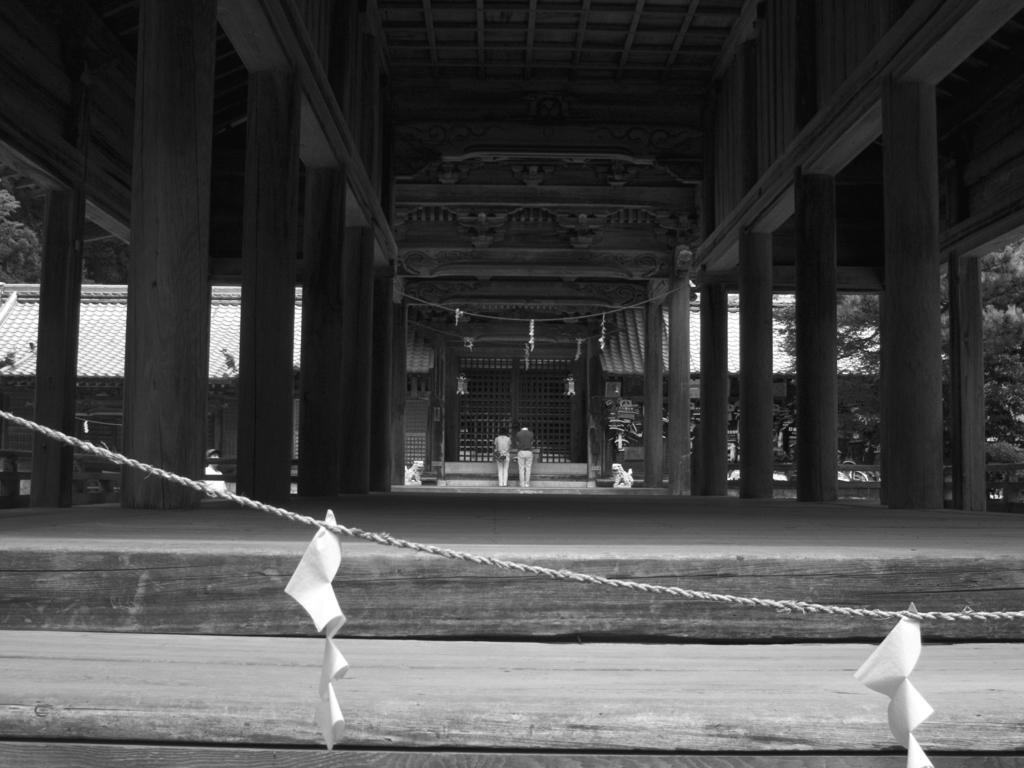Please provide a concise description of this image. This is a black and white image. In this image there is a rope. On the rope there are some papers hanged. There is a building with pillars. On the right side there are trees. 